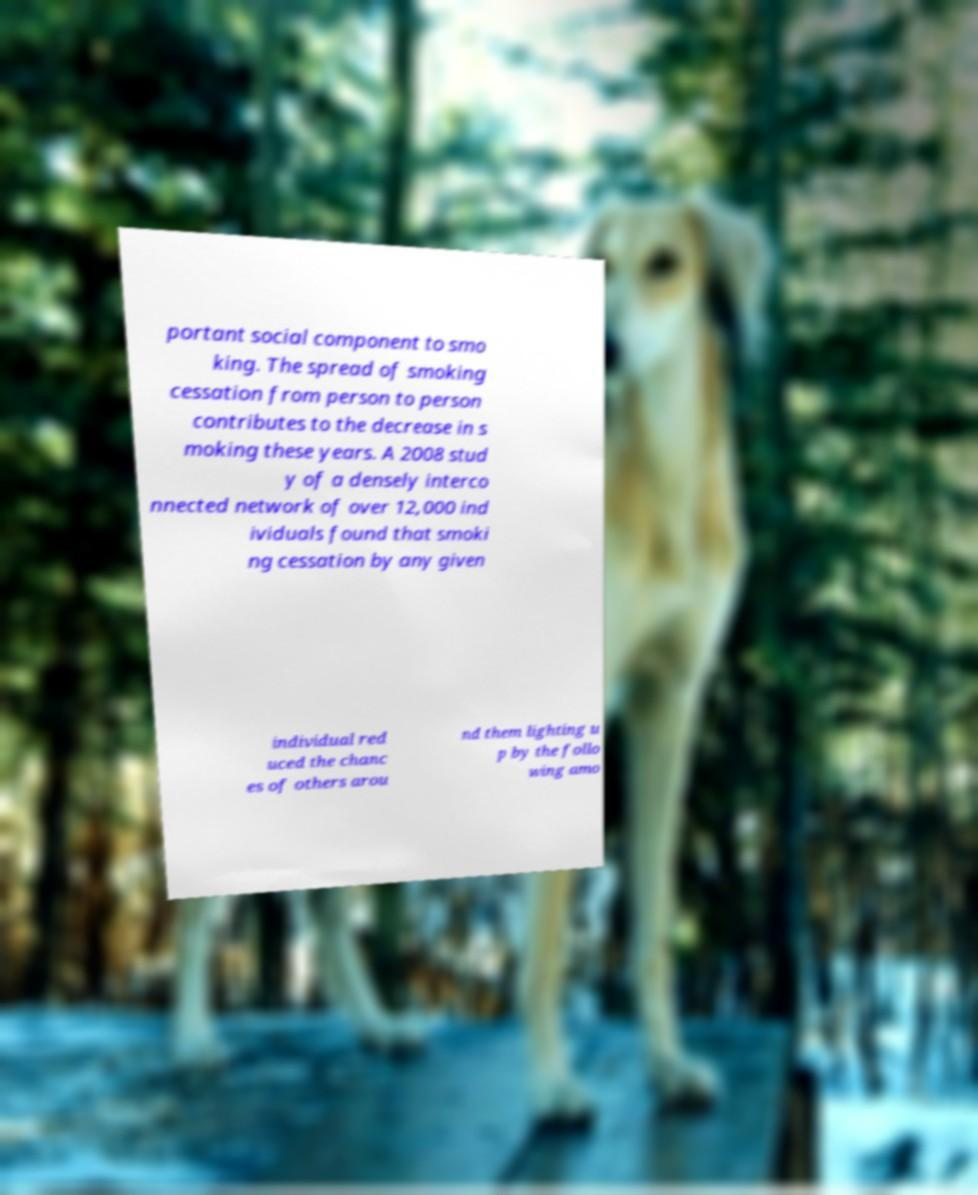What messages or text are displayed in this image? I need them in a readable, typed format. portant social component to smo king. The spread of smoking cessation from person to person contributes to the decrease in s moking these years. A 2008 stud y of a densely interco nnected network of over 12,000 ind ividuals found that smoki ng cessation by any given individual red uced the chanc es of others arou nd them lighting u p by the follo wing amo 